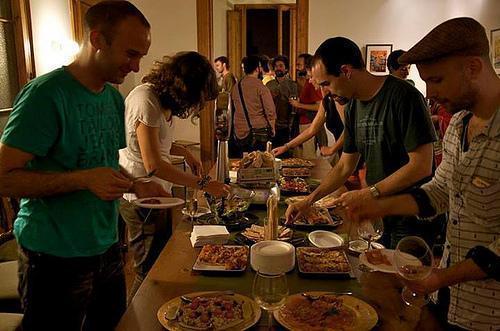How many men have green shirts on?
Give a very brief answer. 2. How many women have curly hair?
Give a very brief answer. 1. How many pieces of framed artwork are on the walls?
Give a very brief answer. 2. 